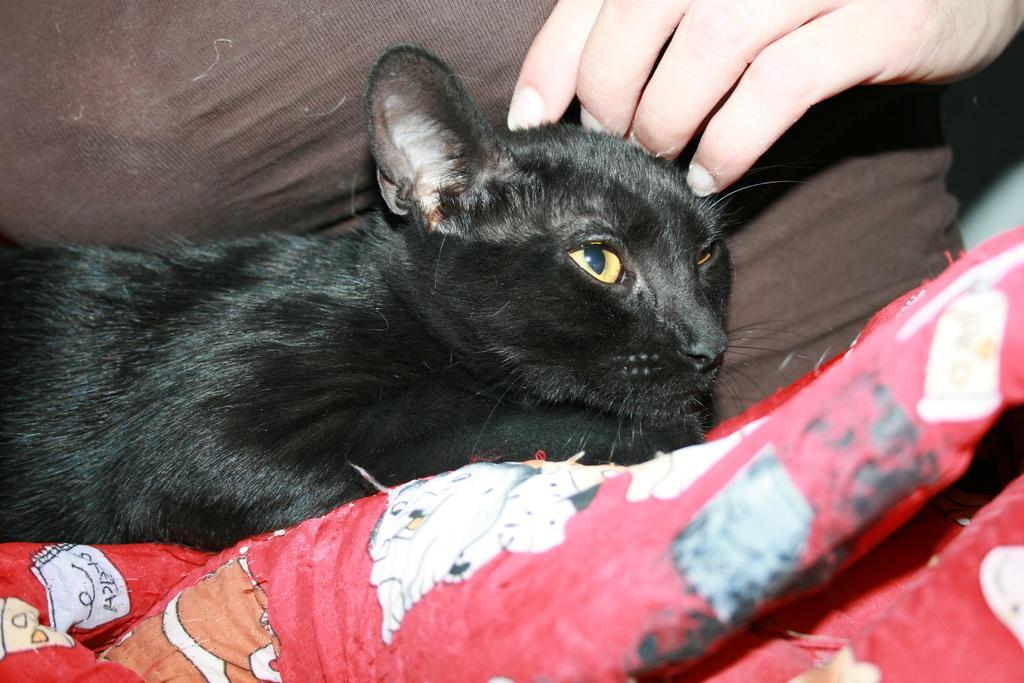Could you give a brief overview of what you see in this image? In the middle of the image there is a cat lying on the lap of a person. At the bottom of the image there is a bed sheet. At the top of the image there is a person. 